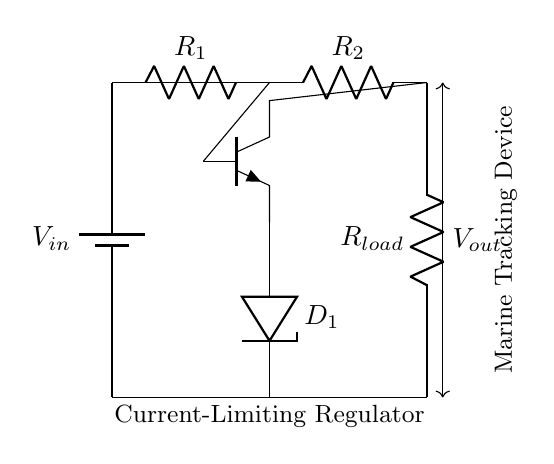What is the input voltage for this circuit? The input voltage is labeled as V in the circuit diagram, which represents the source that supplies power to the regulator.
Answer: V in What type of transistor is used in this circuit? The diagram indicates an NPN transistor is used. The notation npn specifies the type of bipolar junction transistor depicted.
Answer: NPN What is the function of the Zener diode in this regulator? The Zener diode, D1, is used for voltage regulation, ensuring the output voltage remains constant at a certain level even if the input voltage varies.
Answer: Voltage regulation How many resistors are present in this circuit? The circuit includes three resistors: R1, R2, and R load, identified in the schematic.
Answer: Three What is the purpose of the current-limiting regulator in this circuit? The current-limiting regulator prevents excess current from flowing into the load, thereby protecting the marine tracking device from damage due to overcurrent conditions.
Answer: Prevent excess current What is the output voltage indicated in the circuit? The output voltage \( V out \) is represented in the diagram, and it is located at the load resistor's output, where the voltage is regulated.
Answer: V out What components are outputting the current to the marine tracking device? The current is supplied to the marine tracking device through the load resistor R load, which is directly connected to the output voltage \( V out \).
Answer: R load 